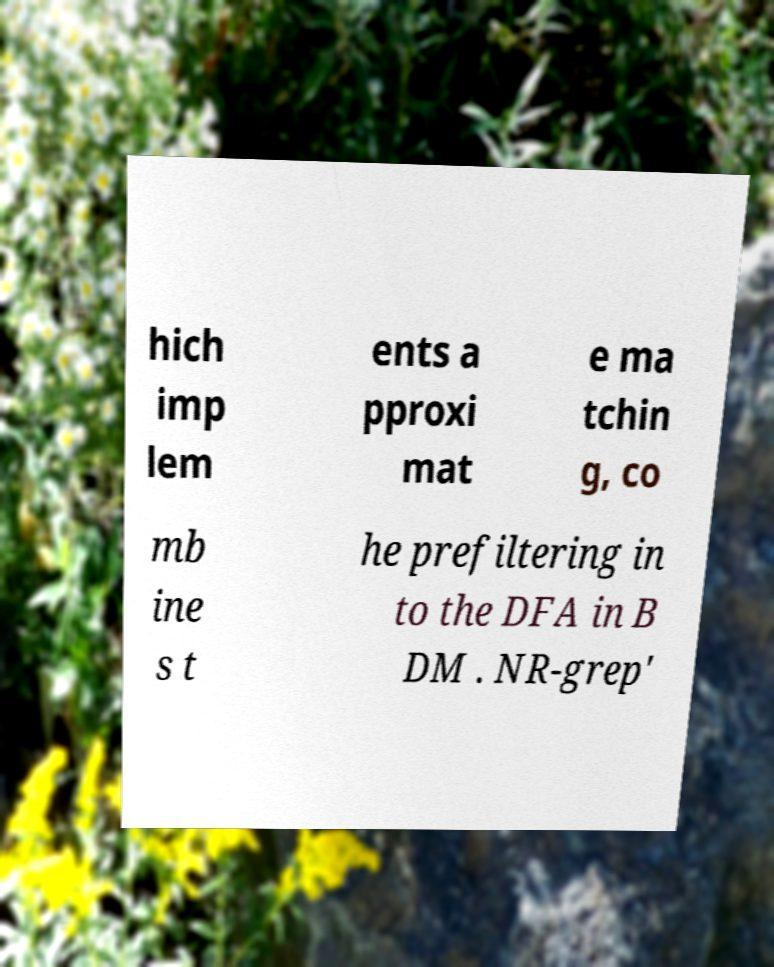I need the written content from this picture converted into text. Can you do that? hich imp lem ents a pproxi mat e ma tchin g, co mb ine s t he prefiltering in to the DFA in B DM . NR-grep' 